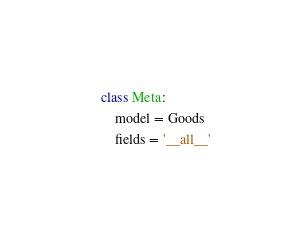<code> <loc_0><loc_0><loc_500><loc_500><_Python_>
    class Meta:
        model = Goods
        fields = '__all__'
</code> 